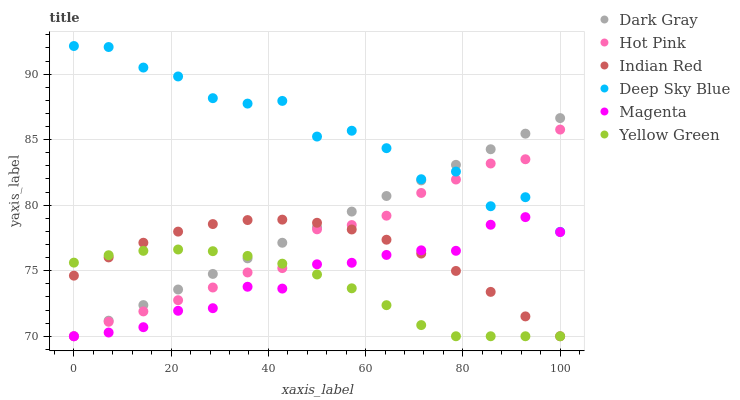Does Yellow Green have the minimum area under the curve?
Answer yes or no. Yes. Does Deep Sky Blue have the maximum area under the curve?
Answer yes or no. Yes. Does Hot Pink have the minimum area under the curve?
Answer yes or no. No. Does Hot Pink have the maximum area under the curve?
Answer yes or no. No. Is Dark Gray the smoothest?
Answer yes or no. Yes. Is Deep Sky Blue the roughest?
Answer yes or no. Yes. Is Hot Pink the smoothest?
Answer yes or no. No. Is Hot Pink the roughest?
Answer yes or no. No. Does Indian Red have the lowest value?
Answer yes or no. Yes. Does Deep Sky Blue have the lowest value?
Answer yes or no. No. Does Deep Sky Blue have the highest value?
Answer yes or no. Yes. Does Hot Pink have the highest value?
Answer yes or no. No. Is Magenta less than Deep Sky Blue?
Answer yes or no. Yes. Is Deep Sky Blue greater than Indian Red?
Answer yes or no. Yes. Does Hot Pink intersect Magenta?
Answer yes or no. Yes. Is Hot Pink less than Magenta?
Answer yes or no. No. Is Hot Pink greater than Magenta?
Answer yes or no. No. Does Magenta intersect Deep Sky Blue?
Answer yes or no. No. 